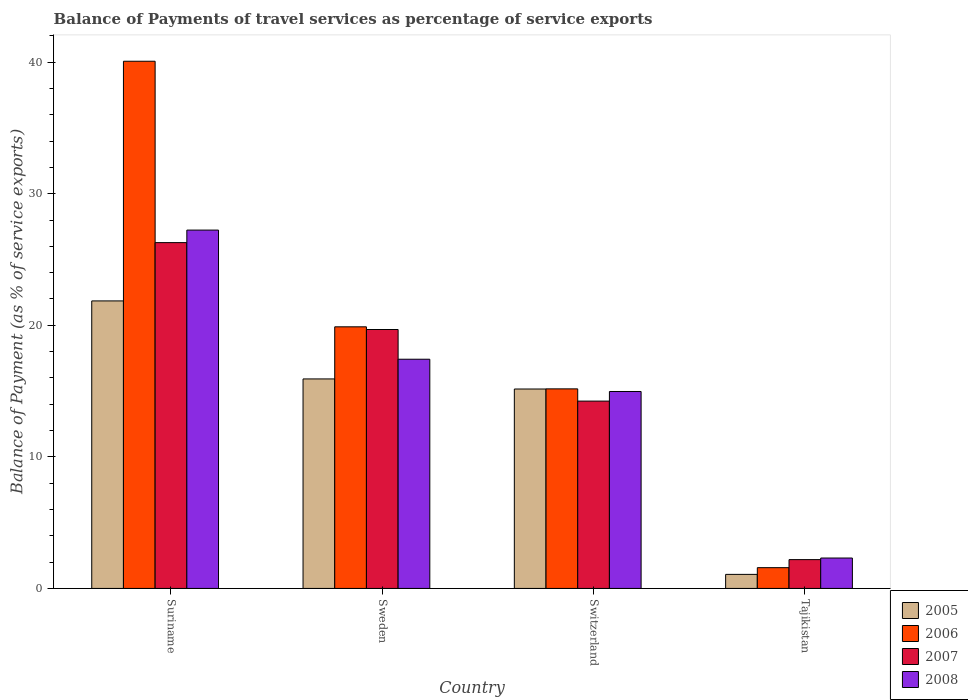How many groups of bars are there?
Ensure brevity in your answer.  4. Are the number of bars per tick equal to the number of legend labels?
Your response must be concise. Yes. How many bars are there on the 4th tick from the right?
Offer a terse response. 4. What is the label of the 4th group of bars from the left?
Your response must be concise. Tajikistan. What is the balance of payments of travel services in 2007 in Switzerland?
Give a very brief answer. 14.24. Across all countries, what is the maximum balance of payments of travel services in 2008?
Give a very brief answer. 27.23. Across all countries, what is the minimum balance of payments of travel services in 2006?
Offer a very short reply. 1.58. In which country was the balance of payments of travel services in 2006 maximum?
Keep it short and to the point. Suriname. In which country was the balance of payments of travel services in 2008 minimum?
Your response must be concise. Tajikistan. What is the total balance of payments of travel services in 2008 in the graph?
Make the answer very short. 61.93. What is the difference between the balance of payments of travel services in 2006 in Suriname and that in Sweden?
Offer a very short reply. 20.18. What is the difference between the balance of payments of travel services in 2005 in Sweden and the balance of payments of travel services in 2006 in Tajikistan?
Provide a succinct answer. 14.34. What is the average balance of payments of travel services in 2008 per country?
Keep it short and to the point. 15.48. What is the difference between the balance of payments of travel services of/in 2008 and balance of payments of travel services of/in 2006 in Switzerland?
Your answer should be compact. -0.2. What is the ratio of the balance of payments of travel services in 2005 in Suriname to that in Switzerland?
Offer a terse response. 1.44. Is the balance of payments of travel services in 2006 in Sweden less than that in Switzerland?
Provide a succinct answer. No. Is the difference between the balance of payments of travel services in 2008 in Sweden and Switzerland greater than the difference between the balance of payments of travel services in 2006 in Sweden and Switzerland?
Provide a short and direct response. No. What is the difference between the highest and the second highest balance of payments of travel services in 2005?
Offer a terse response. -6.7. What is the difference between the highest and the lowest balance of payments of travel services in 2005?
Offer a terse response. 20.78. What does the 4th bar from the left in Suriname represents?
Your response must be concise. 2008. How many bars are there?
Give a very brief answer. 16. What is the difference between two consecutive major ticks on the Y-axis?
Provide a succinct answer. 10. Are the values on the major ticks of Y-axis written in scientific E-notation?
Your answer should be very brief. No. Does the graph contain any zero values?
Your response must be concise. No. How are the legend labels stacked?
Provide a short and direct response. Vertical. What is the title of the graph?
Make the answer very short. Balance of Payments of travel services as percentage of service exports. Does "2006" appear as one of the legend labels in the graph?
Give a very brief answer. Yes. What is the label or title of the Y-axis?
Provide a succinct answer. Balance of Payment (as % of service exports). What is the Balance of Payment (as % of service exports) in 2005 in Suriname?
Make the answer very short. 21.85. What is the Balance of Payment (as % of service exports) of 2006 in Suriname?
Give a very brief answer. 40.07. What is the Balance of Payment (as % of service exports) in 2007 in Suriname?
Your answer should be very brief. 26.28. What is the Balance of Payment (as % of service exports) of 2008 in Suriname?
Keep it short and to the point. 27.23. What is the Balance of Payment (as % of service exports) of 2005 in Sweden?
Give a very brief answer. 15.92. What is the Balance of Payment (as % of service exports) of 2006 in Sweden?
Your answer should be very brief. 19.88. What is the Balance of Payment (as % of service exports) of 2007 in Sweden?
Keep it short and to the point. 19.68. What is the Balance of Payment (as % of service exports) of 2008 in Sweden?
Ensure brevity in your answer.  17.42. What is the Balance of Payment (as % of service exports) of 2005 in Switzerland?
Your answer should be compact. 15.16. What is the Balance of Payment (as % of service exports) in 2006 in Switzerland?
Provide a short and direct response. 15.17. What is the Balance of Payment (as % of service exports) in 2007 in Switzerland?
Make the answer very short. 14.24. What is the Balance of Payment (as % of service exports) in 2008 in Switzerland?
Provide a succinct answer. 14.97. What is the Balance of Payment (as % of service exports) of 2005 in Tajikistan?
Your answer should be compact. 1.07. What is the Balance of Payment (as % of service exports) of 2006 in Tajikistan?
Keep it short and to the point. 1.58. What is the Balance of Payment (as % of service exports) of 2007 in Tajikistan?
Offer a very short reply. 2.19. What is the Balance of Payment (as % of service exports) in 2008 in Tajikistan?
Provide a succinct answer. 2.31. Across all countries, what is the maximum Balance of Payment (as % of service exports) in 2005?
Provide a short and direct response. 21.85. Across all countries, what is the maximum Balance of Payment (as % of service exports) of 2006?
Offer a very short reply. 40.07. Across all countries, what is the maximum Balance of Payment (as % of service exports) of 2007?
Give a very brief answer. 26.28. Across all countries, what is the maximum Balance of Payment (as % of service exports) of 2008?
Your answer should be very brief. 27.23. Across all countries, what is the minimum Balance of Payment (as % of service exports) in 2005?
Your response must be concise. 1.07. Across all countries, what is the minimum Balance of Payment (as % of service exports) of 2006?
Give a very brief answer. 1.58. Across all countries, what is the minimum Balance of Payment (as % of service exports) in 2007?
Give a very brief answer. 2.19. Across all countries, what is the minimum Balance of Payment (as % of service exports) of 2008?
Provide a succinct answer. 2.31. What is the total Balance of Payment (as % of service exports) of 2005 in the graph?
Offer a terse response. 54. What is the total Balance of Payment (as % of service exports) of 2006 in the graph?
Your response must be concise. 76.7. What is the total Balance of Payment (as % of service exports) in 2007 in the graph?
Keep it short and to the point. 62.39. What is the total Balance of Payment (as % of service exports) of 2008 in the graph?
Your response must be concise. 61.93. What is the difference between the Balance of Payment (as % of service exports) of 2005 in Suriname and that in Sweden?
Provide a short and direct response. 5.93. What is the difference between the Balance of Payment (as % of service exports) in 2006 in Suriname and that in Sweden?
Your answer should be compact. 20.18. What is the difference between the Balance of Payment (as % of service exports) of 2007 in Suriname and that in Sweden?
Your answer should be very brief. 6.6. What is the difference between the Balance of Payment (as % of service exports) in 2008 in Suriname and that in Sweden?
Your answer should be compact. 9.81. What is the difference between the Balance of Payment (as % of service exports) of 2005 in Suriname and that in Switzerland?
Offer a very short reply. 6.7. What is the difference between the Balance of Payment (as % of service exports) of 2006 in Suriname and that in Switzerland?
Your response must be concise. 24.9. What is the difference between the Balance of Payment (as % of service exports) of 2007 in Suriname and that in Switzerland?
Make the answer very short. 12.04. What is the difference between the Balance of Payment (as % of service exports) in 2008 in Suriname and that in Switzerland?
Offer a very short reply. 12.27. What is the difference between the Balance of Payment (as % of service exports) of 2005 in Suriname and that in Tajikistan?
Keep it short and to the point. 20.78. What is the difference between the Balance of Payment (as % of service exports) in 2006 in Suriname and that in Tajikistan?
Make the answer very short. 38.49. What is the difference between the Balance of Payment (as % of service exports) of 2007 in Suriname and that in Tajikistan?
Keep it short and to the point. 24.09. What is the difference between the Balance of Payment (as % of service exports) of 2008 in Suriname and that in Tajikistan?
Make the answer very short. 24.92. What is the difference between the Balance of Payment (as % of service exports) of 2005 in Sweden and that in Switzerland?
Your response must be concise. 0.77. What is the difference between the Balance of Payment (as % of service exports) of 2006 in Sweden and that in Switzerland?
Give a very brief answer. 4.72. What is the difference between the Balance of Payment (as % of service exports) of 2007 in Sweden and that in Switzerland?
Ensure brevity in your answer.  5.44. What is the difference between the Balance of Payment (as % of service exports) of 2008 in Sweden and that in Switzerland?
Offer a very short reply. 2.45. What is the difference between the Balance of Payment (as % of service exports) of 2005 in Sweden and that in Tajikistan?
Offer a terse response. 14.85. What is the difference between the Balance of Payment (as % of service exports) in 2006 in Sweden and that in Tajikistan?
Provide a short and direct response. 18.3. What is the difference between the Balance of Payment (as % of service exports) of 2007 in Sweden and that in Tajikistan?
Offer a very short reply. 17.49. What is the difference between the Balance of Payment (as % of service exports) in 2008 in Sweden and that in Tajikistan?
Keep it short and to the point. 15.11. What is the difference between the Balance of Payment (as % of service exports) in 2005 in Switzerland and that in Tajikistan?
Keep it short and to the point. 14.09. What is the difference between the Balance of Payment (as % of service exports) of 2006 in Switzerland and that in Tajikistan?
Your answer should be very brief. 13.59. What is the difference between the Balance of Payment (as % of service exports) of 2007 in Switzerland and that in Tajikistan?
Provide a succinct answer. 12.05. What is the difference between the Balance of Payment (as % of service exports) in 2008 in Switzerland and that in Tajikistan?
Offer a very short reply. 12.66. What is the difference between the Balance of Payment (as % of service exports) of 2005 in Suriname and the Balance of Payment (as % of service exports) of 2006 in Sweden?
Ensure brevity in your answer.  1.97. What is the difference between the Balance of Payment (as % of service exports) of 2005 in Suriname and the Balance of Payment (as % of service exports) of 2007 in Sweden?
Your answer should be compact. 2.17. What is the difference between the Balance of Payment (as % of service exports) in 2005 in Suriname and the Balance of Payment (as % of service exports) in 2008 in Sweden?
Your answer should be compact. 4.43. What is the difference between the Balance of Payment (as % of service exports) of 2006 in Suriname and the Balance of Payment (as % of service exports) of 2007 in Sweden?
Provide a short and direct response. 20.39. What is the difference between the Balance of Payment (as % of service exports) in 2006 in Suriname and the Balance of Payment (as % of service exports) in 2008 in Sweden?
Give a very brief answer. 22.65. What is the difference between the Balance of Payment (as % of service exports) in 2007 in Suriname and the Balance of Payment (as % of service exports) in 2008 in Sweden?
Offer a very short reply. 8.86. What is the difference between the Balance of Payment (as % of service exports) of 2005 in Suriname and the Balance of Payment (as % of service exports) of 2006 in Switzerland?
Offer a very short reply. 6.68. What is the difference between the Balance of Payment (as % of service exports) in 2005 in Suriname and the Balance of Payment (as % of service exports) in 2007 in Switzerland?
Provide a short and direct response. 7.61. What is the difference between the Balance of Payment (as % of service exports) in 2005 in Suriname and the Balance of Payment (as % of service exports) in 2008 in Switzerland?
Give a very brief answer. 6.88. What is the difference between the Balance of Payment (as % of service exports) of 2006 in Suriname and the Balance of Payment (as % of service exports) of 2007 in Switzerland?
Offer a very short reply. 25.83. What is the difference between the Balance of Payment (as % of service exports) of 2006 in Suriname and the Balance of Payment (as % of service exports) of 2008 in Switzerland?
Give a very brief answer. 25.1. What is the difference between the Balance of Payment (as % of service exports) of 2007 in Suriname and the Balance of Payment (as % of service exports) of 2008 in Switzerland?
Your answer should be compact. 11.31. What is the difference between the Balance of Payment (as % of service exports) of 2005 in Suriname and the Balance of Payment (as % of service exports) of 2006 in Tajikistan?
Offer a very short reply. 20.27. What is the difference between the Balance of Payment (as % of service exports) in 2005 in Suriname and the Balance of Payment (as % of service exports) in 2007 in Tajikistan?
Provide a short and direct response. 19.66. What is the difference between the Balance of Payment (as % of service exports) in 2005 in Suriname and the Balance of Payment (as % of service exports) in 2008 in Tajikistan?
Make the answer very short. 19.54. What is the difference between the Balance of Payment (as % of service exports) of 2006 in Suriname and the Balance of Payment (as % of service exports) of 2007 in Tajikistan?
Ensure brevity in your answer.  37.88. What is the difference between the Balance of Payment (as % of service exports) of 2006 in Suriname and the Balance of Payment (as % of service exports) of 2008 in Tajikistan?
Give a very brief answer. 37.76. What is the difference between the Balance of Payment (as % of service exports) of 2007 in Suriname and the Balance of Payment (as % of service exports) of 2008 in Tajikistan?
Give a very brief answer. 23.97. What is the difference between the Balance of Payment (as % of service exports) of 2005 in Sweden and the Balance of Payment (as % of service exports) of 2006 in Switzerland?
Your answer should be compact. 0.76. What is the difference between the Balance of Payment (as % of service exports) of 2005 in Sweden and the Balance of Payment (as % of service exports) of 2007 in Switzerland?
Provide a succinct answer. 1.69. What is the difference between the Balance of Payment (as % of service exports) in 2005 in Sweden and the Balance of Payment (as % of service exports) in 2008 in Switzerland?
Ensure brevity in your answer.  0.96. What is the difference between the Balance of Payment (as % of service exports) in 2006 in Sweden and the Balance of Payment (as % of service exports) in 2007 in Switzerland?
Your answer should be very brief. 5.65. What is the difference between the Balance of Payment (as % of service exports) in 2006 in Sweden and the Balance of Payment (as % of service exports) in 2008 in Switzerland?
Ensure brevity in your answer.  4.92. What is the difference between the Balance of Payment (as % of service exports) in 2007 in Sweden and the Balance of Payment (as % of service exports) in 2008 in Switzerland?
Ensure brevity in your answer.  4.71. What is the difference between the Balance of Payment (as % of service exports) in 2005 in Sweden and the Balance of Payment (as % of service exports) in 2006 in Tajikistan?
Your answer should be compact. 14.34. What is the difference between the Balance of Payment (as % of service exports) in 2005 in Sweden and the Balance of Payment (as % of service exports) in 2007 in Tajikistan?
Give a very brief answer. 13.73. What is the difference between the Balance of Payment (as % of service exports) of 2005 in Sweden and the Balance of Payment (as % of service exports) of 2008 in Tajikistan?
Your answer should be very brief. 13.61. What is the difference between the Balance of Payment (as % of service exports) in 2006 in Sweden and the Balance of Payment (as % of service exports) in 2007 in Tajikistan?
Provide a succinct answer. 17.69. What is the difference between the Balance of Payment (as % of service exports) of 2006 in Sweden and the Balance of Payment (as % of service exports) of 2008 in Tajikistan?
Your response must be concise. 17.57. What is the difference between the Balance of Payment (as % of service exports) in 2007 in Sweden and the Balance of Payment (as % of service exports) in 2008 in Tajikistan?
Provide a short and direct response. 17.37. What is the difference between the Balance of Payment (as % of service exports) in 2005 in Switzerland and the Balance of Payment (as % of service exports) in 2006 in Tajikistan?
Keep it short and to the point. 13.58. What is the difference between the Balance of Payment (as % of service exports) in 2005 in Switzerland and the Balance of Payment (as % of service exports) in 2007 in Tajikistan?
Offer a very short reply. 12.97. What is the difference between the Balance of Payment (as % of service exports) in 2005 in Switzerland and the Balance of Payment (as % of service exports) in 2008 in Tajikistan?
Provide a short and direct response. 12.85. What is the difference between the Balance of Payment (as % of service exports) in 2006 in Switzerland and the Balance of Payment (as % of service exports) in 2007 in Tajikistan?
Your response must be concise. 12.98. What is the difference between the Balance of Payment (as % of service exports) of 2006 in Switzerland and the Balance of Payment (as % of service exports) of 2008 in Tajikistan?
Provide a succinct answer. 12.86. What is the difference between the Balance of Payment (as % of service exports) of 2007 in Switzerland and the Balance of Payment (as % of service exports) of 2008 in Tajikistan?
Ensure brevity in your answer.  11.93. What is the average Balance of Payment (as % of service exports) of 2005 per country?
Offer a terse response. 13.5. What is the average Balance of Payment (as % of service exports) in 2006 per country?
Offer a very short reply. 19.17. What is the average Balance of Payment (as % of service exports) of 2007 per country?
Your answer should be compact. 15.6. What is the average Balance of Payment (as % of service exports) of 2008 per country?
Provide a short and direct response. 15.48. What is the difference between the Balance of Payment (as % of service exports) of 2005 and Balance of Payment (as % of service exports) of 2006 in Suriname?
Make the answer very short. -18.22. What is the difference between the Balance of Payment (as % of service exports) in 2005 and Balance of Payment (as % of service exports) in 2007 in Suriname?
Ensure brevity in your answer.  -4.43. What is the difference between the Balance of Payment (as % of service exports) of 2005 and Balance of Payment (as % of service exports) of 2008 in Suriname?
Your answer should be very brief. -5.38. What is the difference between the Balance of Payment (as % of service exports) of 2006 and Balance of Payment (as % of service exports) of 2007 in Suriname?
Provide a short and direct response. 13.79. What is the difference between the Balance of Payment (as % of service exports) of 2006 and Balance of Payment (as % of service exports) of 2008 in Suriname?
Offer a very short reply. 12.83. What is the difference between the Balance of Payment (as % of service exports) of 2007 and Balance of Payment (as % of service exports) of 2008 in Suriname?
Offer a terse response. -0.95. What is the difference between the Balance of Payment (as % of service exports) of 2005 and Balance of Payment (as % of service exports) of 2006 in Sweden?
Offer a terse response. -3.96. What is the difference between the Balance of Payment (as % of service exports) of 2005 and Balance of Payment (as % of service exports) of 2007 in Sweden?
Provide a short and direct response. -3.76. What is the difference between the Balance of Payment (as % of service exports) of 2005 and Balance of Payment (as % of service exports) of 2008 in Sweden?
Keep it short and to the point. -1.5. What is the difference between the Balance of Payment (as % of service exports) of 2006 and Balance of Payment (as % of service exports) of 2007 in Sweden?
Provide a short and direct response. 0.2. What is the difference between the Balance of Payment (as % of service exports) of 2006 and Balance of Payment (as % of service exports) of 2008 in Sweden?
Provide a succinct answer. 2.46. What is the difference between the Balance of Payment (as % of service exports) in 2007 and Balance of Payment (as % of service exports) in 2008 in Sweden?
Offer a very short reply. 2.26. What is the difference between the Balance of Payment (as % of service exports) of 2005 and Balance of Payment (as % of service exports) of 2006 in Switzerland?
Offer a very short reply. -0.01. What is the difference between the Balance of Payment (as % of service exports) of 2005 and Balance of Payment (as % of service exports) of 2007 in Switzerland?
Provide a succinct answer. 0.92. What is the difference between the Balance of Payment (as % of service exports) in 2005 and Balance of Payment (as % of service exports) in 2008 in Switzerland?
Make the answer very short. 0.19. What is the difference between the Balance of Payment (as % of service exports) in 2006 and Balance of Payment (as % of service exports) in 2007 in Switzerland?
Your response must be concise. 0.93. What is the difference between the Balance of Payment (as % of service exports) in 2006 and Balance of Payment (as % of service exports) in 2008 in Switzerland?
Provide a short and direct response. 0.2. What is the difference between the Balance of Payment (as % of service exports) in 2007 and Balance of Payment (as % of service exports) in 2008 in Switzerland?
Make the answer very short. -0.73. What is the difference between the Balance of Payment (as % of service exports) of 2005 and Balance of Payment (as % of service exports) of 2006 in Tajikistan?
Ensure brevity in your answer.  -0.51. What is the difference between the Balance of Payment (as % of service exports) in 2005 and Balance of Payment (as % of service exports) in 2007 in Tajikistan?
Ensure brevity in your answer.  -1.12. What is the difference between the Balance of Payment (as % of service exports) of 2005 and Balance of Payment (as % of service exports) of 2008 in Tajikistan?
Your response must be concise. -1.24. What is the difference between the Balance of Payment (as % of service exports) of 2006 and Balance of Payment (as % of service exports) of 2007 in Tajikistan?
Provide a short and direct response. -0.61. What is the difference between the Balance of Payment (as % of service exports) in 2006 and Balance of Payment (as % of service exports) in 2008 in Tajikistan?
Give a very brief answer. -0.73. What is the difference between the Balance of Payment (as % of service exports) of 2007 and Balance of Payment (as % of service exports) of 2008 in Tajikistan?
Your response must be concise. -0.12. What is the ratio of the Balance of Payment (as % of service exports) in 2005 in Suriname to that in Sweden?
Keep it short and to the point. 1.37. What is the ratio of the Balance of Payment (as % of service exports) of 2006 in Suriname to that in Sweden?
Ensure brevity in your answer.  2.02. What is the ratio of the Balance of Payment (as % of service exports) of 2007 in Suriname to that in Sweden?
Make the answer very short. 1.34. What is the ratio of the Balance of Payment (as % of service exports) of 2008 in Suriname to that in Sweden?
Provide a succinct answer. 1.56. What is the ratio of the Balance of Payment (as % of service exports) in 2005 in Suriname to that in Switzerland?
Give a very brief answer. 1.44. What is the ratio of the Balance of Payment (as % of service exports) of 2006 in Suriname to that in Switzerland?
Your answer should be compact. 2.64. What is the ratio of the Balance of Payment (as % of service exports) of 2007 in Suriname to that in Switzerland?
Your response must be concise. 1.85. What is the ratio of the Balance of Payment (as % of service exports) of 2008 in Suriname to that in Switzerland?
Ensure brevity in your answer.  1.82. What is the ratio of the Balance of Payment (as % of service exports) in 2005 in Suriname to that in Tajikistan?
Offer a terse response. 20.46. What is the ratio of the Balance of Payment (as % of service exports) of 2006 in Suriname to that in Tajikistan?
Provide a short and direct response. 25.38. What is the ratio of the Balance of Payment (as % of service exports) of 2007 in Suriname to that in Tajikistan?
Give a very brief answer. 12. What is the ratio of the Balance of Payment (as % of service exports) of 2008 in Suriname to that in Tajikistan?
Your answer should be very brief. 11.79. What is the ratio of the Balance of Payment (as % of service exports) of 2005 in Sweden to that in Switzerland?
Keep it short and to the point. 1.05. What is the ratio of the Balance of Payment (as % of service exports) of 2006 in Sweden to that in Switzerland?
Offer a terse response. 1.31. What is the ratio of the Balance of Payment (as % of service exports) in 2007 in Sweden to that in Switzerland?
Keep it short and to the point. 1.38. What is the ratio of the Balance of Payment (as % of service exports) in 2008 in Sweden to that in Switzerland?
Your answer should be compact. 1.16. What is the ratio of the Balance of Payment (as % of service exports) in 2005 in Sweden to that in Tajikistan?
Offer a very short reply. 14.91. What is the ratio of the Balance of Payment (as % of service exports) of 2006 in Sweden to that in Tajikistan?
Keep it short and to the point. 12.59. What is the ratio of the Balance of Payment (as % of service exports) of 2007 in Sweden to that in Tajikistan?
Offer a terse response. 8.99. What is the ratio of the Balance of Payment (as % of service exports) of 2008 in Sweden to that in Tajikistan?
Provide a short and direct response. 7.54. What is the ratio of the Balance of Payment (as % of service exports) in 2005 in Switzerland to that in Tajikistan?
Keep it short and to the point. 14.19. What is the ratio of the Balance of Payment (as % of service exports) in 2006 in Switzerland to that in Tajikistan?
Your answer should be very brief. 9.61. What is the ratio of the Balance of Payment (as % of service exports) of 2007 in Switzerland to that in Tajikistan?
Give a very brief answer. 6.5. What is the ratio of the Balance of Payment (as % of service exports) in 2008 in Switzerland to that in Tajikistan?
Provide a succinct answer. 6.48. What is the difference between the highest and the second highest Balance of Payment (as % of service exports) in 2005?
Make the answer very short. 5.93. What is the difference between the highest and the second highest Balance of Payment (as % of service exports) of 2006?
Provide a short and direct response. 20.18. What is the difference between the highest and the second highest Balance of Payment (as % of service exports) in 2007?
Provide a short and direct response. 6.6. What is the difference between the highest and the second highest Balance of Payment (as % of service exports) in 2008?
Offer a terse response. 9.81. What is the difference between the highest and the lowest Balance of Payment (as % of service exports) of 2005?
Your response must be concise. 20.78. What is the difference between the highest and the lowest Balance of Payment (as % of service exports) in 2006?
Provide a short and direct response. 38.49. What is the difference between the highest and the lowest Balance of Payment (as % of service exports) of 2007?
Your answer should be very brief. 24.09. What is the difference between the highest and the lowest Balance of Payment (as % of service exports) in 2008?
Make the answer very short. 24.92. 